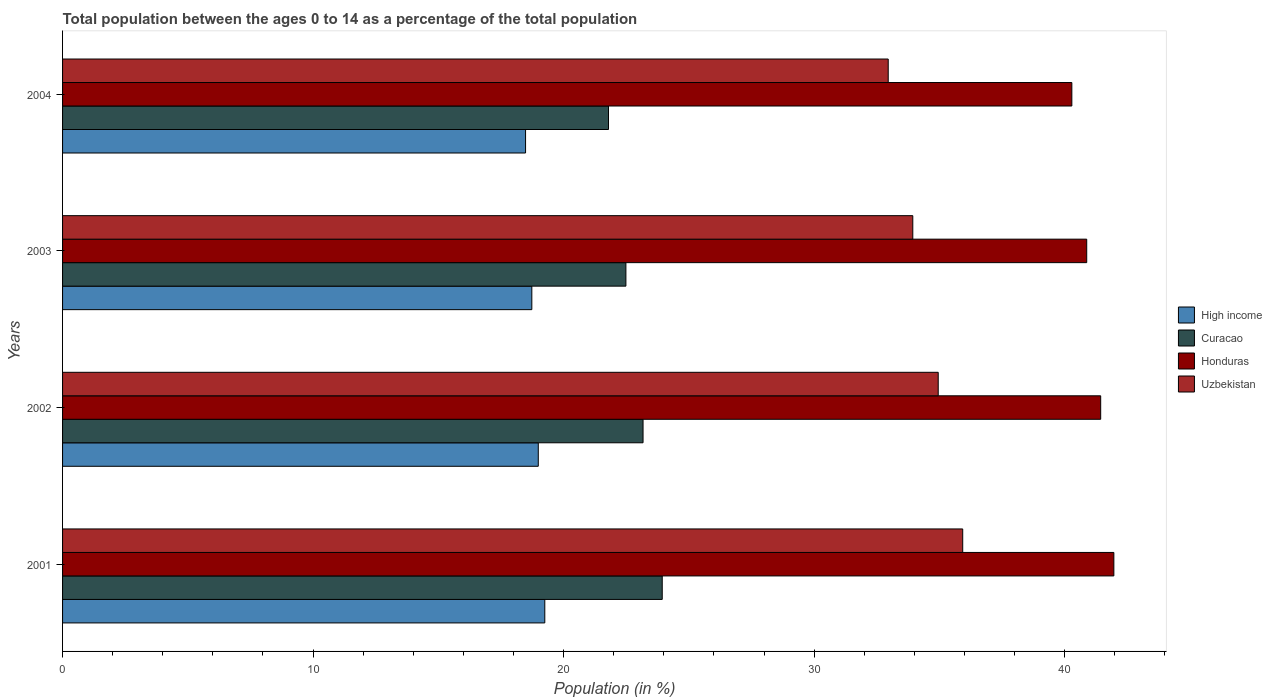How many groups of bars are there?
Offer a very short reply. 4. Are the number of bars per tick equal to the number of legend labels?
Your response must be concise. Yes. Are the number of bars on each tick of the Y-axis equal?
Provide a short and direct response. Yes. How many bars are there on the 4th tick from the bottom?
Keep it short and to the point. 4. What is the percentage of the population ages 0 to 14 in Uzbekistan in 2004?
Provide a short and direct response. 32.96. Across all years, what is the maximum percentage of the population ages 0 to 14 in Curacao?
Your answer should be very brief. 23.94. Across all years, what is the minimum percentage of the population ages 0 to 14 in Honduras?
Offer a terse response. 40.29. In which year was the percentage of the population ages 0 to 14 in High income maximum?
Your response must be concise. 2001. What is the total percentage of the population ages 0 to 14 in Uzbekistan in the graph?
Make the answer very short. 137.78. What is the difference between the percentage of the population ages 0 to 14 in High income in 2001 and that in 2003?
Your answer should be compact. 0.52. What is the difference between the percentage of the population ages 0 to 14 in Uzbekistan in 2003 and the percentage of the population ages 0 to 14 in High income in 2002?
Your answer should be compact. 14.95. What is the average percentage of the population ages 0 to 14 in Curacao per year?
Your response must be concise. 22.85. In the year 2004, what is the difference between the percentage of the population ages 0 to 14 in Curacao and percentage of the population ages 0 to 14 in Uzbekistan?
Ensure brevity in your answer.  -11.16. In how many years, is the percentage of the population ages 0 to 14 in High income greater than 20 ?
Offer a terse response. 0. What is the ratio of the percentage of the population ages 0 to 14 in Curacao in 2002 to that in 2004?
Your response must be concise. 1.06. Is the percentage of the population ages 0 to 14 in Honduras in 2001 less than that in 2003?
Offer a terse response. No. Is the difference between the percentage of the population ages 0 to 14 in Curacao in 2002 and 2003 greater than the difference between the percentage of the population ages 0 to 14 in Uzbekistan in 2002 and 2003?
Your response must be concise. No. What is the difference between the highest and the second highest percentage of the population ages 0 to 14 in Honduras?
Offer a very short reply. 0.53. What is the difference between the highest and the lowest percentage of the population ages 0 to 14 in Curacao?
Keep it short and to the point. 2.14. Is it the case that in every year, the sum of the percentage of the population ages 0 to 14 in Uzbekistan and percentage of the population ages 0 to 14 in Honduras is greater than the sum of percentage of the population ages 0 to 14 in Curacao and percentage of the population ages 0 to 14 in High income?
Give a very brief answer. Yes. What does the 1st bar from the bottom in 2004 represents?
Make the answer very short. High income. Is it the case that in every year, the sum of the percentage of the population ages 0 to 14 in High income and percentage of the population ages 0 to 14 in Uzbekistan is greater than the percentage of the population ages 0 to 14 in Curacao?
Offer a very short reply. Yes. How many bars are there?
Your answer should be very brief. 16. Are all the bars in the graph horizontal?
Give a very brief answer. Yes. Are the values on the major ticks of X-axis written in scientific E-notation?
Your response must be concise. No. Does the graph contain grids?
Your answer should be compact. No. Where does the legend appear in the graph?
Offer a terse response. Center right. How many legend labels are there?
Provide a succinct answer. 4. What is the title of the graph?
Make the answer very short. Total population between the ages 0 to 14 as a percentage of the total population. Does "Malawi" appear as one of the legend labels in the graph?
Offer a terse response. No. What is the label or title of the X-axis?
Offer a terse response. Population (in %). What is the label or title of the Y-axis?
Your response must be concise. Years. What is the Population (in %) in High income in 2001?
Keep it short and to the point. 19.25. What is the Population (in %) in Curacao in 2001?
Your response must be concise. 23.94. What is the Population (in %) of Honduras in 2001?
Offer a terse response. 41.96. What is the Population (in %) in Uzbekistan in 2001?
Your answer should be compact. 35.93. What is the Population (in %) of High income in 2002?
Make the answer very short. 18.99. What is the Population (in %) of Curacao in 2002?
Give a very brief answer. 23.17. What is the Population (in %) in Honduras in 2002?
Your response must be concise. 41.44. What is the Population (in %) of Uzbekistan in 2002?
Offer a very short reply. 34.95. What is the Population (in %) of High income in 2003?
Offer a terse response. 18.73. What is the Population (in %) of Curacao in 2003?
Provide a succinct answer. 22.49. What is the Population (in %) in Honduras in 2003?
Offer a very short reply. 40.88. What is the Population (in %) of Uzbekistan in 2003?
Keep it short and to the point. 33.94. What is the Population (in %) in High income in 2004?
Your response must be concise. 18.48. What is the Population (in %) in Curacao in 2004?
Give a very brief answer. 21.79. What is the Population (in %) in Honduras in 2004?
Make the answer very short. 40.29. What is the Population (in %) of Uzbekistan in 2004?
Offer a very short reply. 32.96. Across all years, what is the maximum Population (in %) in High income?
Your answer should be compact. 19.25. Across all years, what is the maximum Population (in %) in Curacao?
Keep it short and to the point. 23.94. Across all years, what is the maximum Population (in %) of Honduras?
Give a very brief answer. 41.96. Across all years, what is the maximum Population (in %) in Uzbekistan?
Your response must be concise. 35.93. Across all years, what is the minimum Population (in %) in High income?
Provide a succinct answer. 18.48. Across all years, what is the minimum Population (in %) of Curacao?
Make the answer very short. 21.79. Across all years, what is the minimum Population (in %) in Honduras?
Your response must be concise. 40.29. Across all years, what is the minimum Population (in %) in Uzbekistan?
Make the answer very short. 32.96. What is the total Population (in %) in High income in the graph?
Your answer should be compact. 75.45. What is the total Population (in %) of Curacao in the graph?
Provide a short and direct response. 91.39. What is the total Population (in %) in Honduras in the graph?
Your answer should be compact. 164.57. What is the total Population (in %) of Uzbekistan in the graph?
Your answer should be compact. 137.78. What is the difference between the Population (in %) of High income in 2001 and that in 2002?
Your answer should be compact. 0.26. What is the difference between the Population (in %) of Curacao in 2001 and that in 2002?
Offer a terse response. 0.77. What is the difference between the Population (in %) of Honduras in 2001 and that in 2002?
Offer a terse response. 0.53. What is the difference between the Population (in %) of Uzbekistan in 2001 and that in 2002?
Your answer should be very brief. 0.98. What is the difference between the Population (in %) of High income in 2001 and that in 2003?
Your answer should be very brief. 0.52. What is the difference between the Population (in %) in Curacao in 2001 and that in 2003?
Ensure brevity in your answer.  1.45. What is the difference between the Population (in %) of Honduras in 2001 and that in 2003?
Offer a very short reply. 1.08. What is the difference between the Population (in %) of Uzbekistan in 2001 and that in 2003?
Provide a short and direct response. 1.99. What is the difference between the Population (in %) of High income in 2001 and that in 2004?
Your answer should be compact. 0.77. What is the difference between the Population (in %) of Curacao in 2001 and that in 2004?
Ensure brevity in your answer.  2.14. What is the difference between the Population (in %) in Honduras in 2001 and that in 2004?
Offer a very short reply. 1.68. What is the difference between the Population (in %) of Uzbekistan in 2001 and that in 2004?
Provide a succinct answer. 2.97. What is the difference between the Population (in %) in High income in 2002 and that in 2003?
Offer a terse response. 0.26. What is the difference between the Population (in %) of Curacao in 2002 and that in 2003?
Make the answer very short. 0.68. What is the difference between the Population (in %) of Honduras in 2002 and that in 2003?
Your answer should be compact. 0.56. What is the difference between the Population (in %) in Uzbekistan in 2002 and that in 2003?
Offer a very short reply. 1.01. What is the difference between the Population (in %) of High income in 2002 and that in 2004?
Keep it short and to the point. 0.51. What is the difference between the Population (in %) in Curacao in 2002 and that in 2004?
Your answer should be very brief. 1.38. What is the difference between the Population (in %) of Honduras in 2002 and that in 2004?
Keep it short and to the point. 1.15. What is the difference between the Population (in %) in Uzbekistan in 2002 and that in 2004?
Provide a short and direct response. 2. What is the difference between the Population (in %) in High income in 2003 and that in 2004?
Your answer should be compact. 0.25. What is the difference between the Population (in %) of Curacao in 2003 and that in 2004?
Provide a short and direct response. 0.69. What is the difference between the Population (in %) in Honduras in 2003 and that in 2004?
Make the answer very short. 0.59. What is the difference between the Population (in %) of Uzbekistan in 2003 and that in 2004?
Make the answer very short. 0.98. What is the difference between the Population (in %) in High income in 2001 and the Population (in %) in Curacao in 2002?
Provide a short and direct response. -3.92. What is the difference between the Population (in %) of High income in 2001 and the Population (in %) of Honduras in 2002?
Offer a very short reply. -22.19. What is the difference between the Population (in %) of High income in 2001 and the Population (in %) of Uzbekistan in 2002?
Ensure brevity in your answer.  -15.7. What is the difference between the Population (in %) of Curacao in 2001 and the Population (in %) of Honduras in 2002?
Offer a very short reply. -17.5. What is the difference between the Population (in %) in Curacao in 2001 and the Population (in %) in Uzbekistan in 2002?
Your answer should be very brief. -11.02. What is the difference between the Population (in %) of Honduras in 2001 and the Population (in %) of Uzbekistan in 2002?
Offer a terse response. 7.01. What is the difference between the Population (in %) in High income in 2001 and the Population (in %) in Curacao in 2003?
Provide a succinct answer. -3.24. What is the difference between the Population (in %) in High income in 2001 and the Population (in %) in Honduras in 2003?
Your answer should be very brief. -21.63. What is the difference between the Population (in %) of High income in 2001 and the Population (in %) of Uzbekistan in 2003?
Provide a succinct answer. -14.69. What is the difference between the Population (in %) of Curacao in 2001 and the Population (in %) of Honduras in 2003?
Your answer should be compact. -16.94. What is the difference between the Population (in %) of Curacao in 2001 and the Population (in %) of Uzbekistan in 2003?
Make the answer very short. -10. What is the difference between the Population (in %) in Honduras in 2001 and the Population (in %) in Uzbekistan in 2003?
Your answer should be very brief. 8.03. What is the difference between the Population (in %) of High income in 2001 and the Population (in %) of Curacao in 2004?
Give a very brief answer. -2.54. What is the difference between the Population (in %) in High income in 2001 and the Population (in %) in Honduras in 2004?
Offer a very short reply. -21.04. What is the difference between the Population (in %) of High income in 2001 and the Population (in %) of Uzbekistan in 2004?
Make the answer very short. -13.71. What is the difference between the Population (in %) of Curacao in 2001 and the Population (in %) of Honduras in 2004?
Your answer should be very brief. -16.35. What is the difference between the Population (in %) of Curacao in 2001 and the Population (in %) of Uzbekistan in 2004?
Your answer should be compact. -9.02. What is the difference between the Population (in %) in Honduras in 2001 and the Population (in %) in Uzbekistan in 2004?
Your response must be concise. 9.01. What is the difference between the Population (in %) in High income in 2002 and the Population (in %) in Curacao in 2003?
Make the answer very short. -3.5. What is the difference between the Population (in %) of High income in 2002 and the Population (in %) of Honduras in 2003?
Give a very brief answer. -21.89. What is the difference between the Population (in %) of High income in 2002 and the Population (in %) of Uzbekistan in 2003?
Your answer should be very brief. -14.95. What is the difference between the Population (in %) in Curacao in 2002 and the Population (in %) in Honduras in 2003?
Keep it short and to the point. -17.71. What is the difference between the Population (in %) of Curacao in 2002 and the Population (in %) of Uzbekistan in 2003?
Keep it short and to the point. -10.77. What is the difference between the Population (in %) in Honduras in 2002 and the Population (in %) in Uzbekistan in 2003?
Provide a succinct answer. 7.5. What is the difference between the Population (in %) in High income in 2002 and the Population (in %) in Curacao in 2004?
Give a very brief answer. -2.8. What is the difference between the Population (in %) of High income in 2002 and the Population (in %) of Honduras in 2004?
Give a very brief answer. -21.3. What is the difference between the Population (in %) of High income in 2002 and the Population (in %) of Uzbekistan in 2004?
Provide a short and direct response. -13.97. What is the difference between the Population (in %) in Curacao in 2002 and the Population (in %) in Honduras in 2004?
Provide a succinct answer. -17.12. What is the difference between the Population (in %) of Curacao in 2002 and the Population (in %) of Uzbekistan in 2004?
Your response must be concise. -9.79. What is the difference between the Population (in %) in Honduras in 2002 and the Population (in %) in Uzbekistan in 2004?
Your response must be concise. 8.48. What is the difference between the Population (in %) in High income in 2003 and the Population (in %) in Curacao in 2004?
Keep it short and to the point. -3.06. What is the difference between the Population (in %) of High income in 2003 and the Population (in %) of Honduras in 2004?
Your response must be concise. -21.56. What is the difference between the Population (in %) in High income in 2003 and the Population (in %) in Uzbekistan in 2004?
Your answer should be very brief. -14.23. What is the difference between the Population (in %) in Curacao in 2003 and the Population (in %) in Honduras in 2004?
Your answer should be compact. -17.8. What is the difference between the Population (in %) in Curacao in 2003 and the Population (in %) in Uzbekistan in 2004?
Make the answer very short. -10.47. What is the difference between the Population (in %) in Honduras in 2003 and the Population (in %) in Uzbekistan in 2004?
Ensure brevity in your answer.  7.92. What is the average Population (in %) of High income per year?
Your answer should be compact. 18.86. What is the average Population (in %) in Curacao per year?
Offer a very short reply. 22.85. What is the average Population (in %) in Honduras per year?
Offer a very short reply. 41.14. What is the average Population (in %) of Uzbekistan per year?
Your answer should be very brief. 34.44. In the year 2001, what is the difference between the Population (in %) of High income and Population (in %) of Curacao?
Provide a succinct answer. -4.69. In the year 2001, what is the difference between the Population (in %) in High income and Population (in %) in Honduras?
Keep it short and to the point. -22.72. In the year 2001, what is the difference between the Population (in %) of High income and Population (in %) of Uzbekistan?
Provide a succinct answer. -16.68. In the year 2001, what is the difference between the Population (in %) in Curacao and Population (in %) in Honduras?
Ensure brevity in your answer.  -18.03. In the year 2001, what is the difference between the Population (in %) of Curacao and Population (in %) of Uzbekistan?
Make the answer very short. -11.99. In the year 2001, what is the difference between the Population (in %) in Honduras and Population (in %) in Uzbekistan?
Keep it short and to the point. 6.03. In the year 2002, what is the difference between the Population (in %) in High income and Population (in %) in Curacao?
Keep it short and to the point. -4.18. In the year 2002, what is the difference between the Population (in %) of High income and Population (in %) of Honduras?
Offer a very short reply. -22.45. In the year 2002, what is the difference between the Population (in %) of High income and Population (in %) of Uzbekistan?
Your answer should be very brief. -15.96. In the year 2002, what is the difference between the Population (in %) in Curacao and Population (in %) in Honduras?
Offer a terse response. -18.27. In the year 2002, what is the difference between the Population (in %) in Curacao and Population (in %) in Uzbekistan?
Provide a short and direct response. -11.78. In the year 2002, what is the difference between the Population (in %) in Honduras and Population (in %) in Uzbekistan?
Give a very brief answer. 6.49. In the year 2003, what is the difference between the Population (in %) in High income and Population (in %) in Curacao?
Your response must be concise. -3.76. In the year 2003, what is the difference between the Population (in %) of High income and Population (in %) of Honduras?
Make the answer very short. -22.15. In the year 2003, what is the difference between the Population (in %) in High income and Population (in %) in Uzbekistan?
Your answer should be compact. -15.21. In the year 2003, what is the difference between the Population (in %) in Curacao and Population (in %) in Honduras?
Your response must be concise. -18.39. In the year 2003, what is the difference between the Population (in %) of Curacao and Population (in %) of Uzbekistan?
Your answer should be compact. -11.45. In the year 2003, what is the difference between the Population (in %) of Honduras and Population (in %) of Uzbekistan?
Offer a terse response. 6.94. In the year 2004, what is the difference between the Population (in %) in High income and Population (in %) in Curacao?
Your response must be concise. -3.31. In the year 2004, what is the difference between the Population (in %) of High income and Population (in %) of Honduras?
Provide a succinct answer. -21.81. In the year 2004, what is the difference between the Population (in %) in High income and Population (in %) in Uzbekistan?
Make the answer very short. -14.48. In the year 2004, what is the difference between the Population (in %) of Curacao and Population (in %) of Honduras?
Keep it short and to the point. -18.5. In the year 2004, what is the difference between the Population (in %) in Curacao and Population (in %) in Uzbekistan?
Provide a short and direct response. -11.16. In the year 2004, what is the difference between the Population (in %) in Honduras and Population (in %) in Uzbekistan?
Your response must be concise. 7.33. What is the ratio of the Population (in %) in High income in 2001 to that in 2002?
Keep it short and to the point. 1.01. What is the ratio of the Population (in %) of Curacao in 2001 to that in 2002?
Provide a short and direct response. 1.03. What is the ratio of the Population (in %) in Honduras in 2001 to that in 2002?
Give a very brief answer. 1.01. What is the ratio of the Population (in %) of Uzbekistan in 2001 to that in 2002?
Offer a terse response. 1.03. What is the ratio of the Population (in %) in High income in 2001 to that in 2003?
Provide a succinct answer. 1.03. What is the ratio of the Population (in %) in Curacao in 2001 to that in 2003?
Provide a succinct answer. 1.06. What is the ratio of the Population (in %) of Honduras in 2001 to that in 2003?
Your response must be concise. 1.03. What is the ratio of the Population (in %) in Uzbekistan in 2001 to that in 2003?
Give a very brief answer. 1.06. What is the ratio of the Population (in %) in High income in 2001 to that in 2004?
Provide a short and direct response. 1.04. What is the ratio of the Population (in %) of Curacao in 2001 to that in 2004?
Your response must be concise. 1.1. What is the ratio of the Population (in %) of Honduras in 2001 to that in 2004?
Keep it short and to the point. 1.04. What is the ratio of the Population (in %) in Uzbekistan in 2001 to that in 2004?
Ensure brevity in your answer.  1.09. What is the ratio of the Population (in %) of High income in 2002 to that in 2003?
Provide a short and direct response. 1.01. What is the ratio of the Population (in %) in Curacao in 2002 to that in 2003?
Your answer should be very brief. 1.03. What is the ratio of the Population (in %) of Honduras in 2002 to that in 2003?
Ensure brevity in your answer.  1.01. What is the ratio of the Population (in %) in Uzbekistan in 2002 to that in 2003?
Offer a terse response. 1.03. What is the ratio of the Population (in %) of High income in 2002 to that in 2004?
Make the answer very short. 1.03. What is the ratio of the Population (in %) of Curacao in 2002 to that in 2004?
Make the answer very short. 1.06. What is the ratio of the Population (in %) of Honduras in 2002 to that in 2004?
Your response must be concise. 1.03. What is the ratio of the Population (in %) in Uzbekistan in 2002 to that in 2004?
Your answer should be compact. 1.06. What is the ratio of the Population (in %) in High income in 2003 to that in 2004?
Keep it short and to the point. 1.01. What is the ratio of the Population (in %) of Curacao in 2003 to that in 2004?
Your response must be concise. 1.03. What is the ratio of the Population (in %) of Honduras in 2003 to that in 2004?
Provide a short and direct response. 1.01. What is the ratio of the Population (in %) in Uzbekistan in 2003 to that in 2004?
Make the answer very short. 1.03. What is the difference between the highest and the second highest Population (in %) in High income?
Your answer should be compact. 0.26. What is the difference between the highest and the second highest Population (in %) of Curacao?
Ensure brevity in your answer.  0.77. What is the difference between the highest and the second highest Population (in %) in Honduras?
Offer a terse response. 0.53. What is the difference between the highest and the second highest Population (in %) in Uzbekistan?
Provide a short and direct response. 0.98. What is the difference between the highest and the lowest Population (in %) of High income?
Ensure brevity in your answer.  0.77. What is the difference between the highest and the lowest Population (in %) in Curacao?
Your answer should be very brief. 2.14. What is the difference between the highest and the lowest Population (in %) of Honduras?
Provide a succinct answer. 1.68. What is the difference between the highest and the lowest Population (in %) of Uzbekistan?
Make the answer very short. 2.97. 